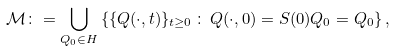Convert formula to latex. <formula><loc_0><loc_0><loc_500><loc_500>\mathcal { M } \colon = \bigcup _ { Q _ { 0 } \in H } \left \{ \{ Q ( \cdot , t ) \} _ { t \geq 0 } \, \colon \, Q ( \cdot , 0 ) = S ( 0 ) Q _ { 0 } = Q _ { 0 } \right \} ,</formula> 